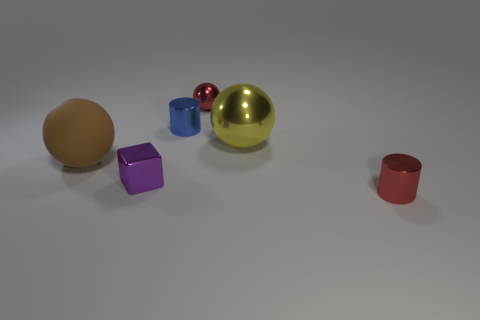Add 3 tiny things. How many objects exist? 9 Subtract all cubes. How many objects are left? 5 Subtract 0 purple cylinders. How many objects are left? 6 Subtract all red balls. Subtract all purple objects. How many objects are left? 4 Add 5 cubes. How many cubes are left? 6 Add 6 big yellow rubber cubes. How many big yellow rubber cubes exist? 6 